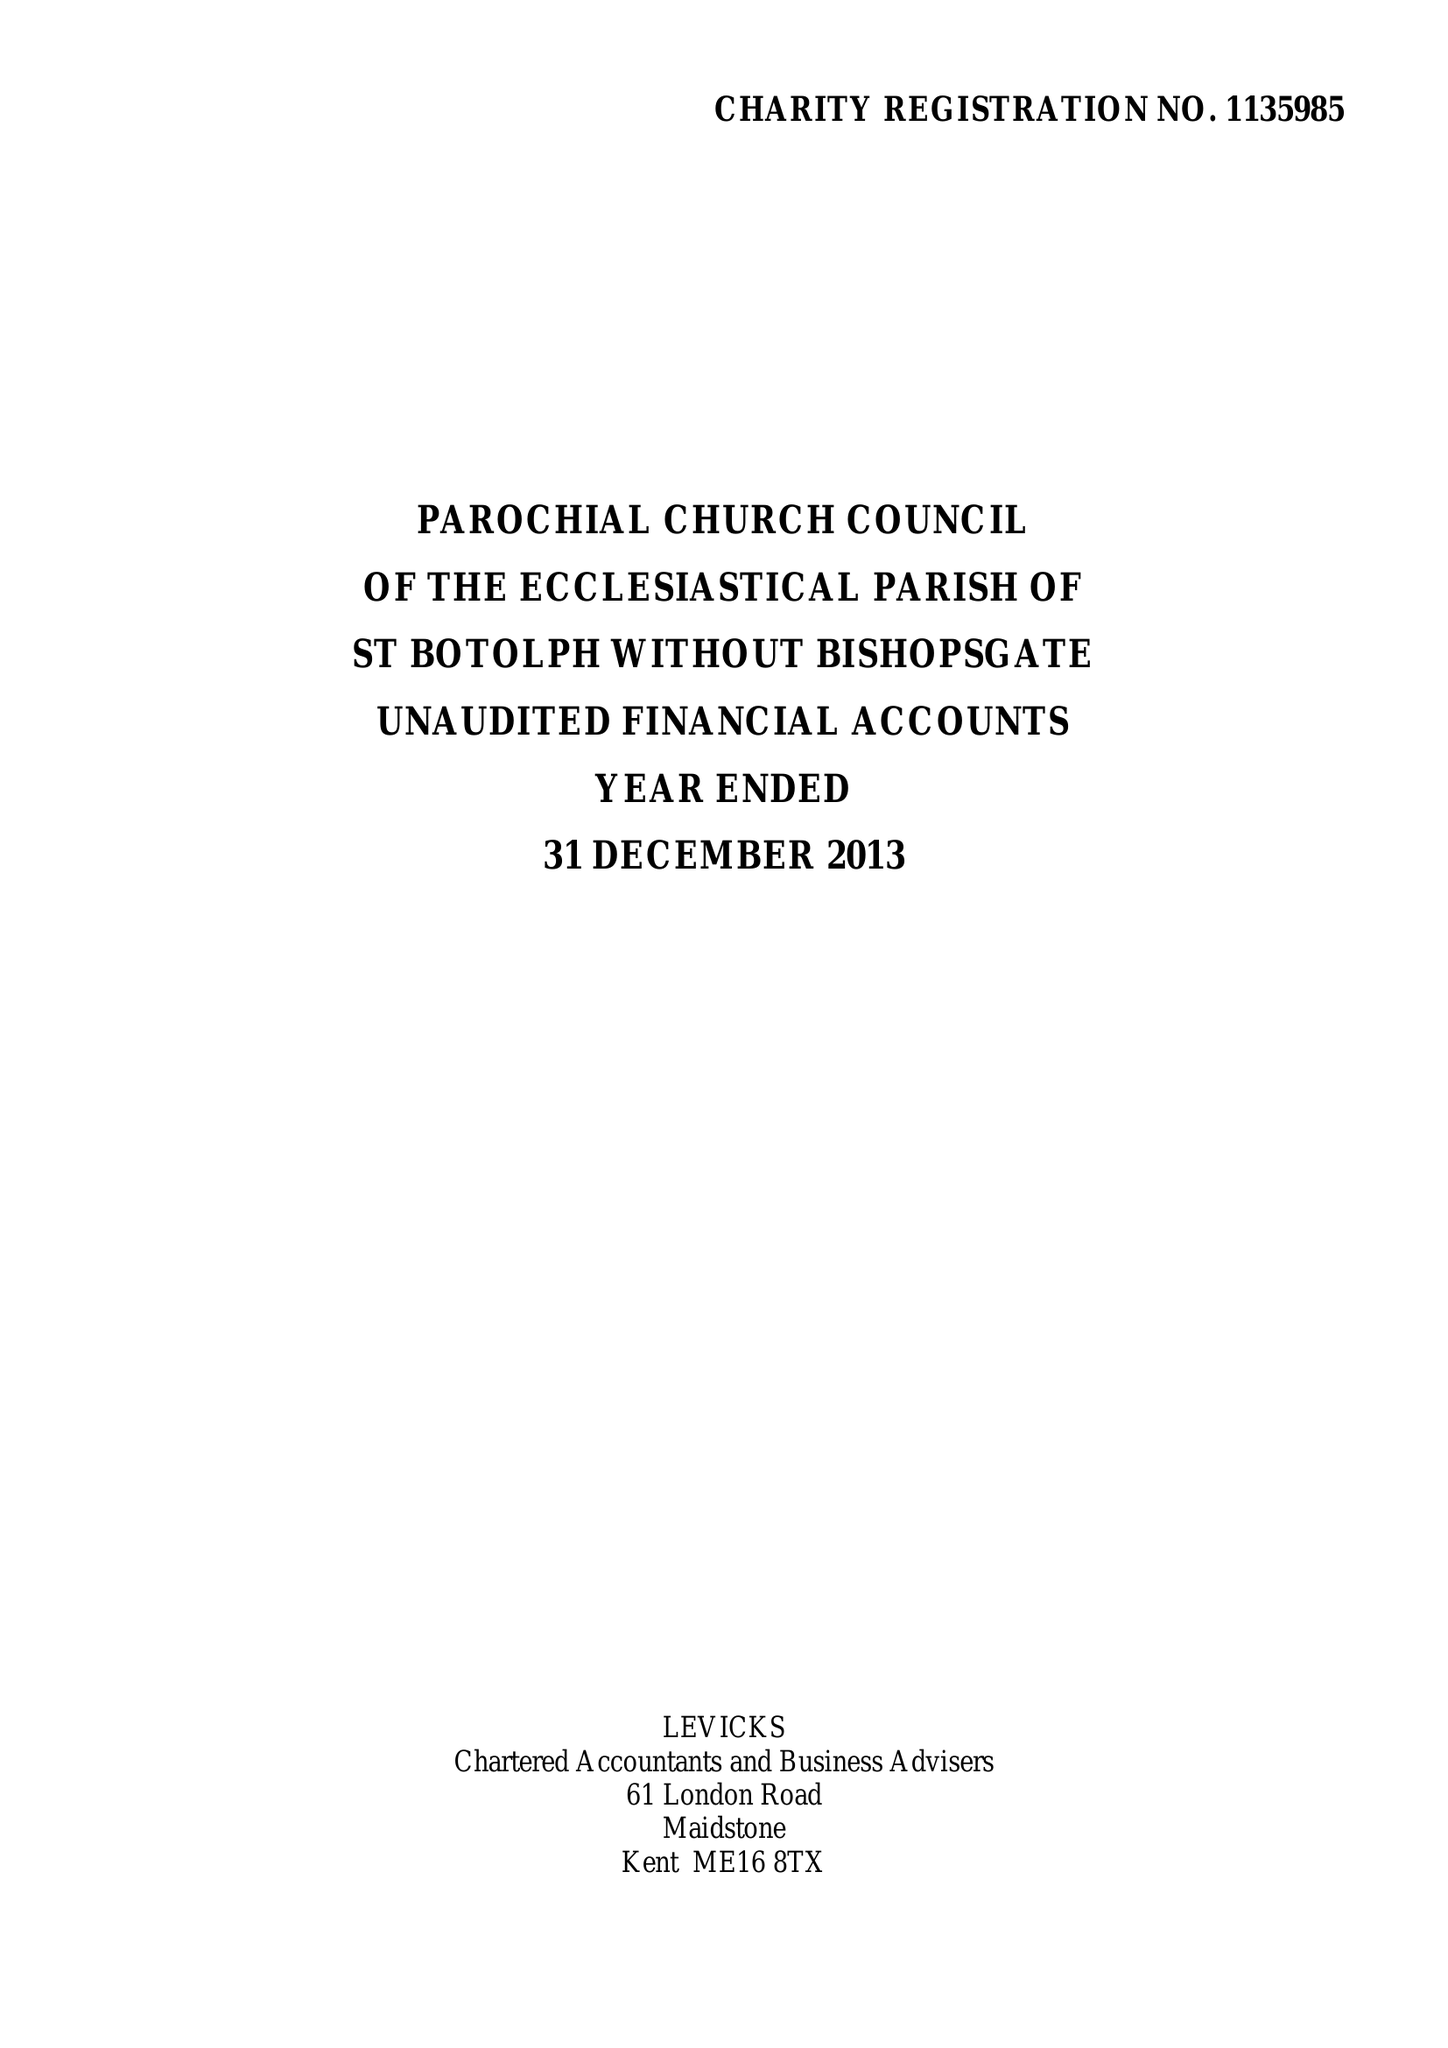What is the value for the charity_number?
Answer the question using a single word or phrase. 1135985 